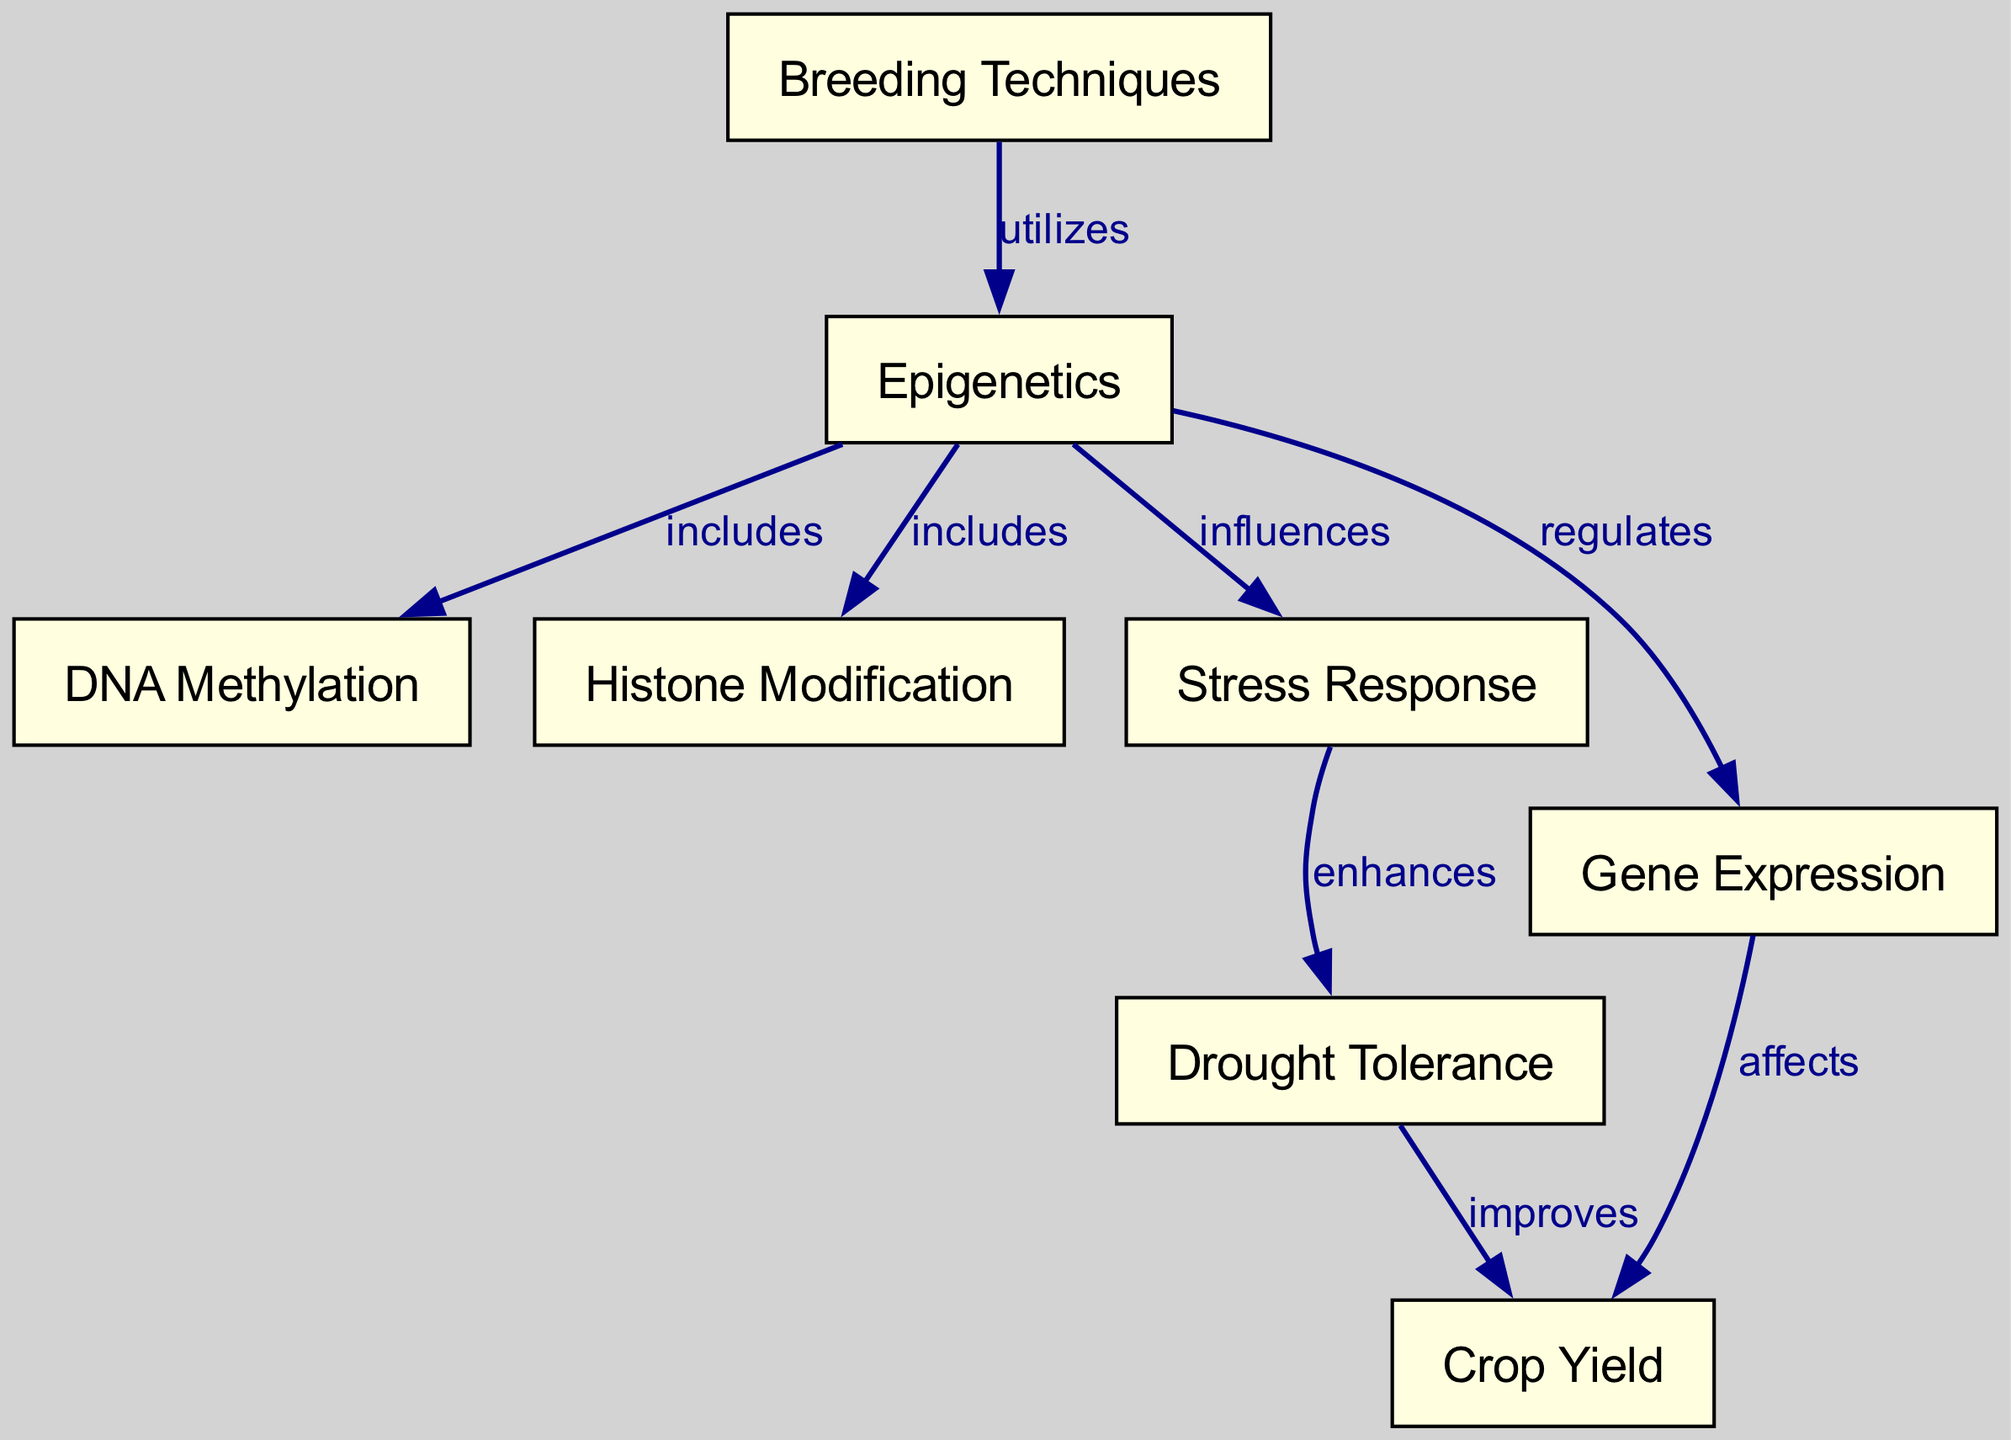What are the two main components included in epigenetics? The diagram shows two edges leading from the "Epigenetics" node to "DNA Methylation" and "Histone Modification," indicating these two components are included in epigenetics.
Answer: DNA Methylation and Histone Modification How many nodes are there in total in the diagram? By counting all the unique nodes presented in the diagram, we find a total of 8 nodes.
Answer: 8 Which concept does stress response enhance? The diagram shows an edge from "Stress Response" to "Drought Tolerance," labeled "enhances," indicating that stress response enhances drought tolerance.
Answer: Drought Tolerance What influences the stress response according to the diagram? The diagram indicates that "Epigenetics" influences "Stress Response" as shown by the directed edge stemming from epigenetics to stress response.
Answer: Epigenetics What is the relationship between gene expression and crop yield? The diagram has an arrow from "Gene Expression" to "Crop Yield," marked as "affects," demonstrating that gene expression affects crop yield.
Answer: Affects What does breeding techniques utilize? The diagram illustrates an edge from "Breeding Techniques" to "Epigenetics" with the label "utilizes," indicating that breeding techniques utilize epigenetics.
Answer: Epigenetics How does drought tolerance impact crop yield? The flow in the diagram shows an edge from "Drought Tolerance" to "Crop Yield," labeled "improves," thus drought tolerance improves crop yield.
Answer: Improves What are the three relationships defined in the diagram? The diagram includes the following relationships: "includes," "influences," and "affects" as labels on different edges, showcasing the nature of connections among the nodes.
Answer: Includes, influences, affects 